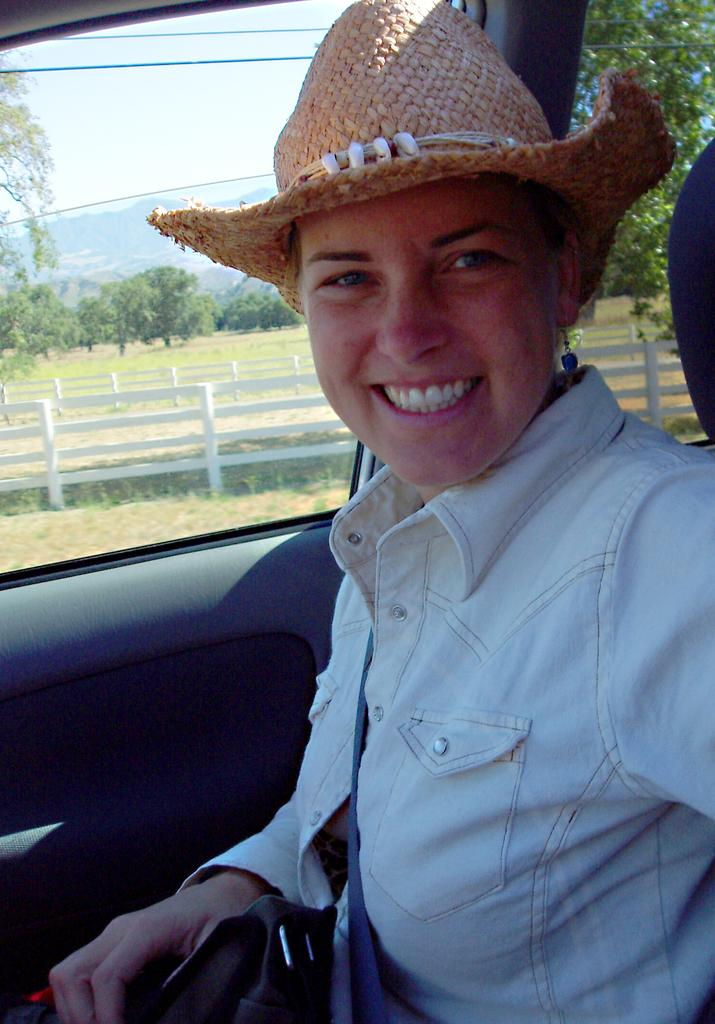Who is present in the image? There is a woman in the image. What is the woman doing in the image? The woman is sitting in a vehicle. What is the woman's facial expression in the image? The woman is smiling. What is the woman wearing in the image? The woman is wearing a shirt and a hat. What can be seen on the left side of the vehicle? There is a window on the left side of the vehicle. What is visible outside the window? Trees are visible outside the window. What type of market is visible outside the window? There is no market visible outside the window; only trees are visible. What is the woman's self-reflection on her outfit in the image? The image does not provide any information about the woman's self-reflection on her outfit. 